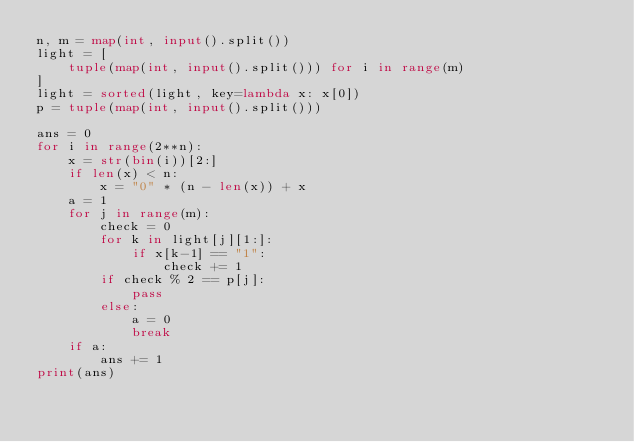<code> <loc_0><loc_0><loc_500><loc_500><_Python_>n, m = map(int, input().split())
light = [
    tuple(map(int, input().split())) for i in range(m)
]
light = sorted(light, key=lambda x: x[0])
p = tuple(map(int, input().split()))

ans = 0
for i in range(2**n):
    x = str(bin(i))[2:]
    if len(x) < n:
        x = "0" * (n - len(x)) + x
    a = 1
    for j in range(m):
        check = 0
        for k in light[j][1:]:
            if x[k-1] == "1":
                check += 1
        if check % 2 == p[j]:
            pass
        else:
            a = 0
            break
    if a:
        ans += 1
print(ans)
</code> 